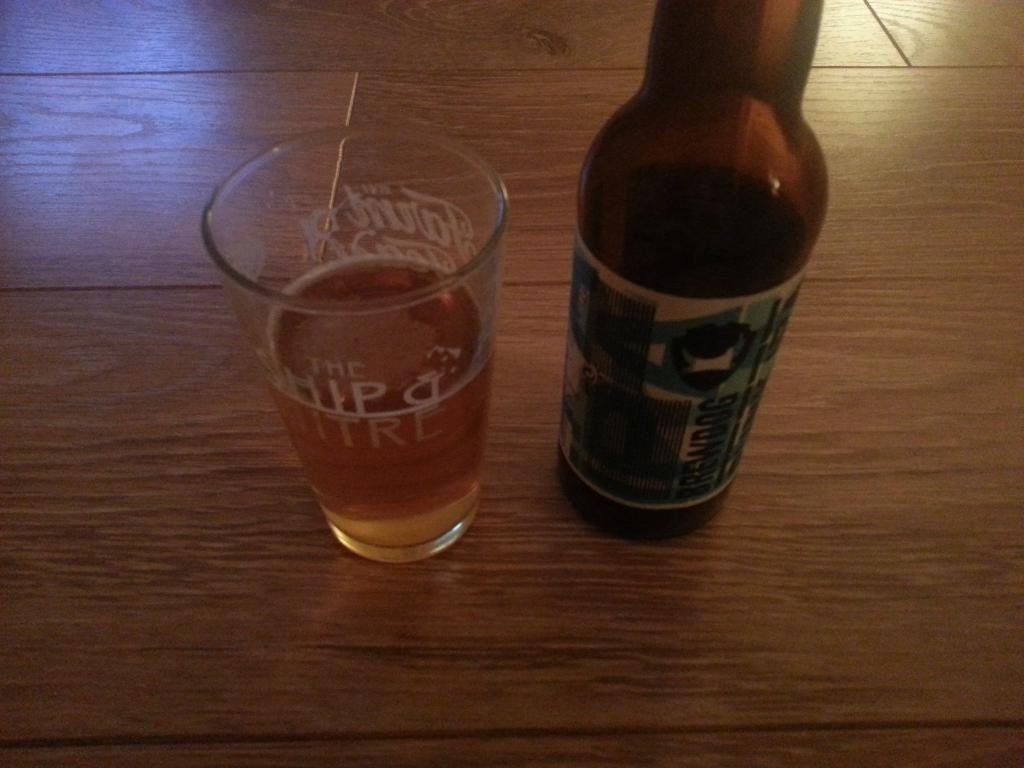What is present in the image that can hold a liquid? There is a glass in the image. What else in the image can hold a liquid? There is a bottle in the image. What is inside the glass in the image? The glass is filled with liquid. What type of behavior can be observed in the dogs in the image? There are no dogs present in the image. What language is spoken by the people in the image? There are no people present in the image. 